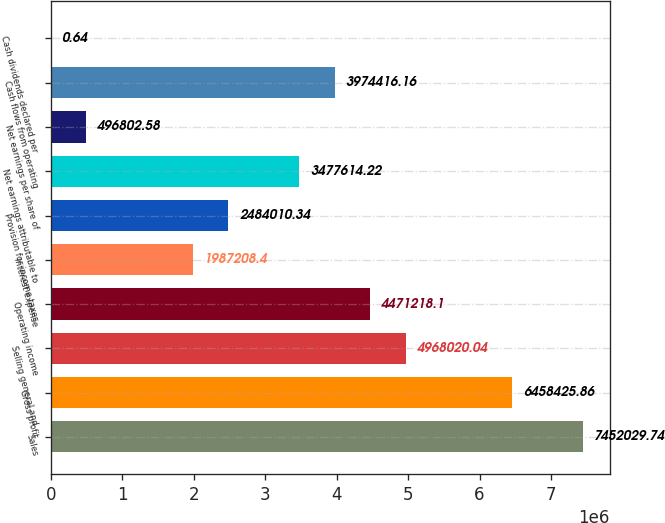<chart> <loc_0><loc_0><loc_500><loc_500><bar_chart><fcel>Sales<fcel>Gross profit<fcel>Selling general and<fcel>Operating income<fcel>Interest expense<fcel>Provision for income taxes<fcel>Net earnings attributable to<fcel>Net earnings per share of<fcel>Cash flows from operating<fcel>Cash dividends declared per<nl><fcel>7.45203e+06<fcel>6.45843e+06<fcel>4.96802e+06<fcel>4.47122e+06<fcel>1.98721e+06<fcel>2.48401e+06<fcel>3.47761e+06<fcel>496803<fcel>3.97442e+06<fcel>0.64<nl></chart> 